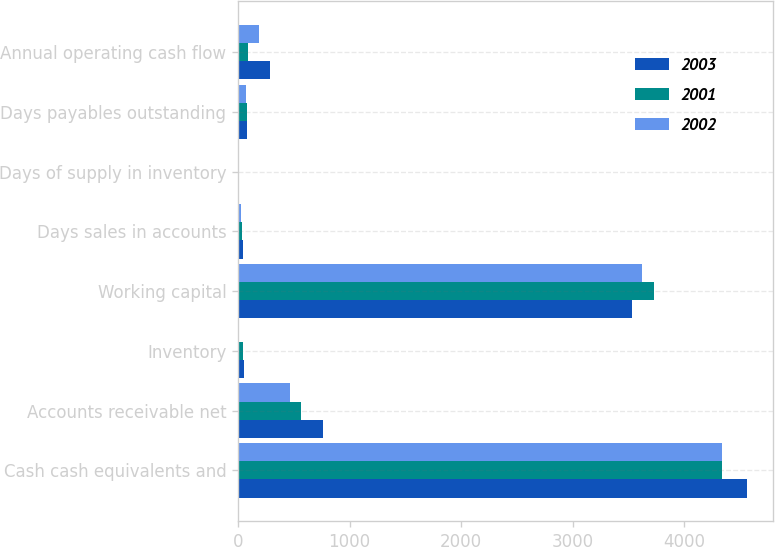<chart> <loc_0><loc_0><loc_500><loc_500><stacked_bar_chart><ecel><fcel>Cash cash equivalents and<fcel>Accounts receivable net<fcel>Inventory<fcel>Working capital<fcel>Days sales in accounts<fcel>Days of supply in inventory<fcel>Days payables outstanding<fcel>Annual operating cash flow<nl><fcel>2003<fcel>4566<fcel>766<fcel>56<fcel>3530<fcel>41<fcel>4<fcel>82<fcel>289<nl><fcel>2001<fcel>4337<fcel>565<fcel>45<fcel>3730<fcel>36<fcel>4<fcel>77<fcel>89<nl><fcel>2002<fcel>4336<fcel>466<fcel>11<fcel>3625<fcel>29<fcel>1<fcel>73<fcel>185<nl></chart> 